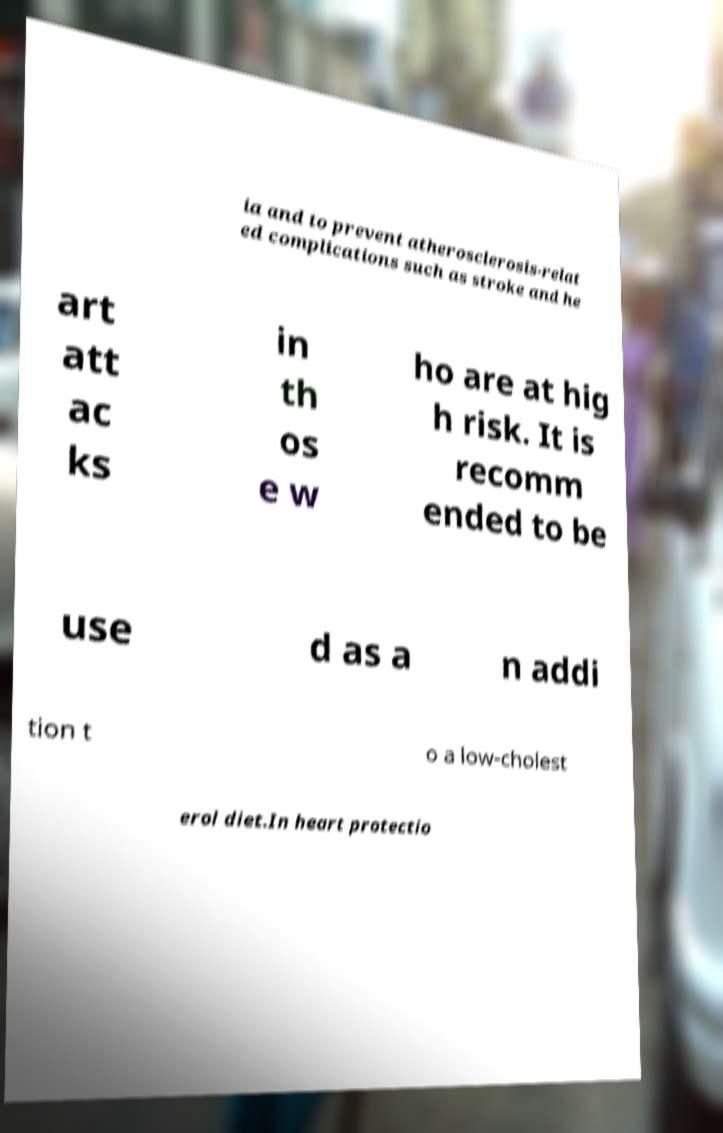For documentation purposes, I need the text within this image transcribed. Could you provide that? ia and to prevent atherosclerosis-relat ed complications such as stroke and he art att ac ks in th os e w ho are at hig h risk. It is recomm ended to be use d as a n addi tion t o a low-cholest erol diet.In heart protectio 